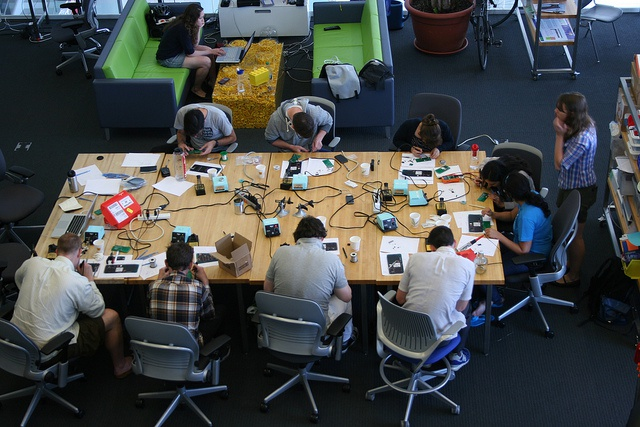Describe the objects in this image and their specific colors. I can see dining table in blue, tan, lightgray, and black tones, couch in blue, black, green, gray, and navy tones, people in blue, darkgray, black, gray, and lightgray tones, couch in blue, black, and green tones, and chair in blue, black, darkblue, and gray tones in this image. 